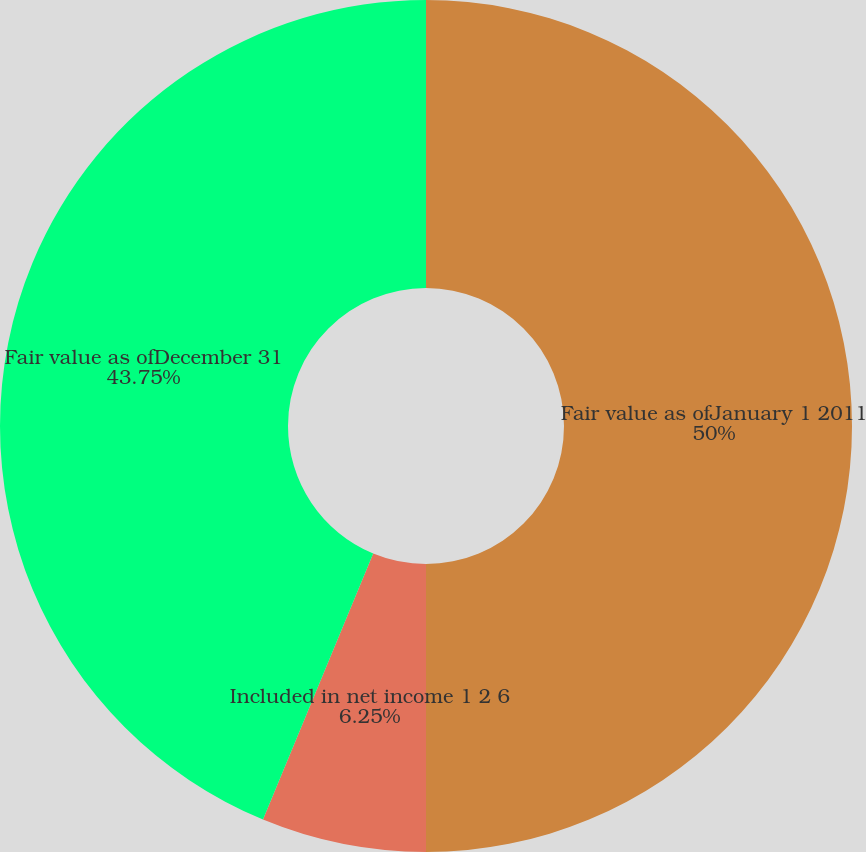Convert chart to OTSL. <chart><loc_0><loc_0><loc_500><loc_500><pie_chart><fcel>Fair value as ofJanuary 1 2011<fcel>Included in net income 1 2 6<fcel>Fair value as ofDecember 31<nl><fcel>50.0%<fcel>6.25%<fcel>43.75%<nl></chart> 